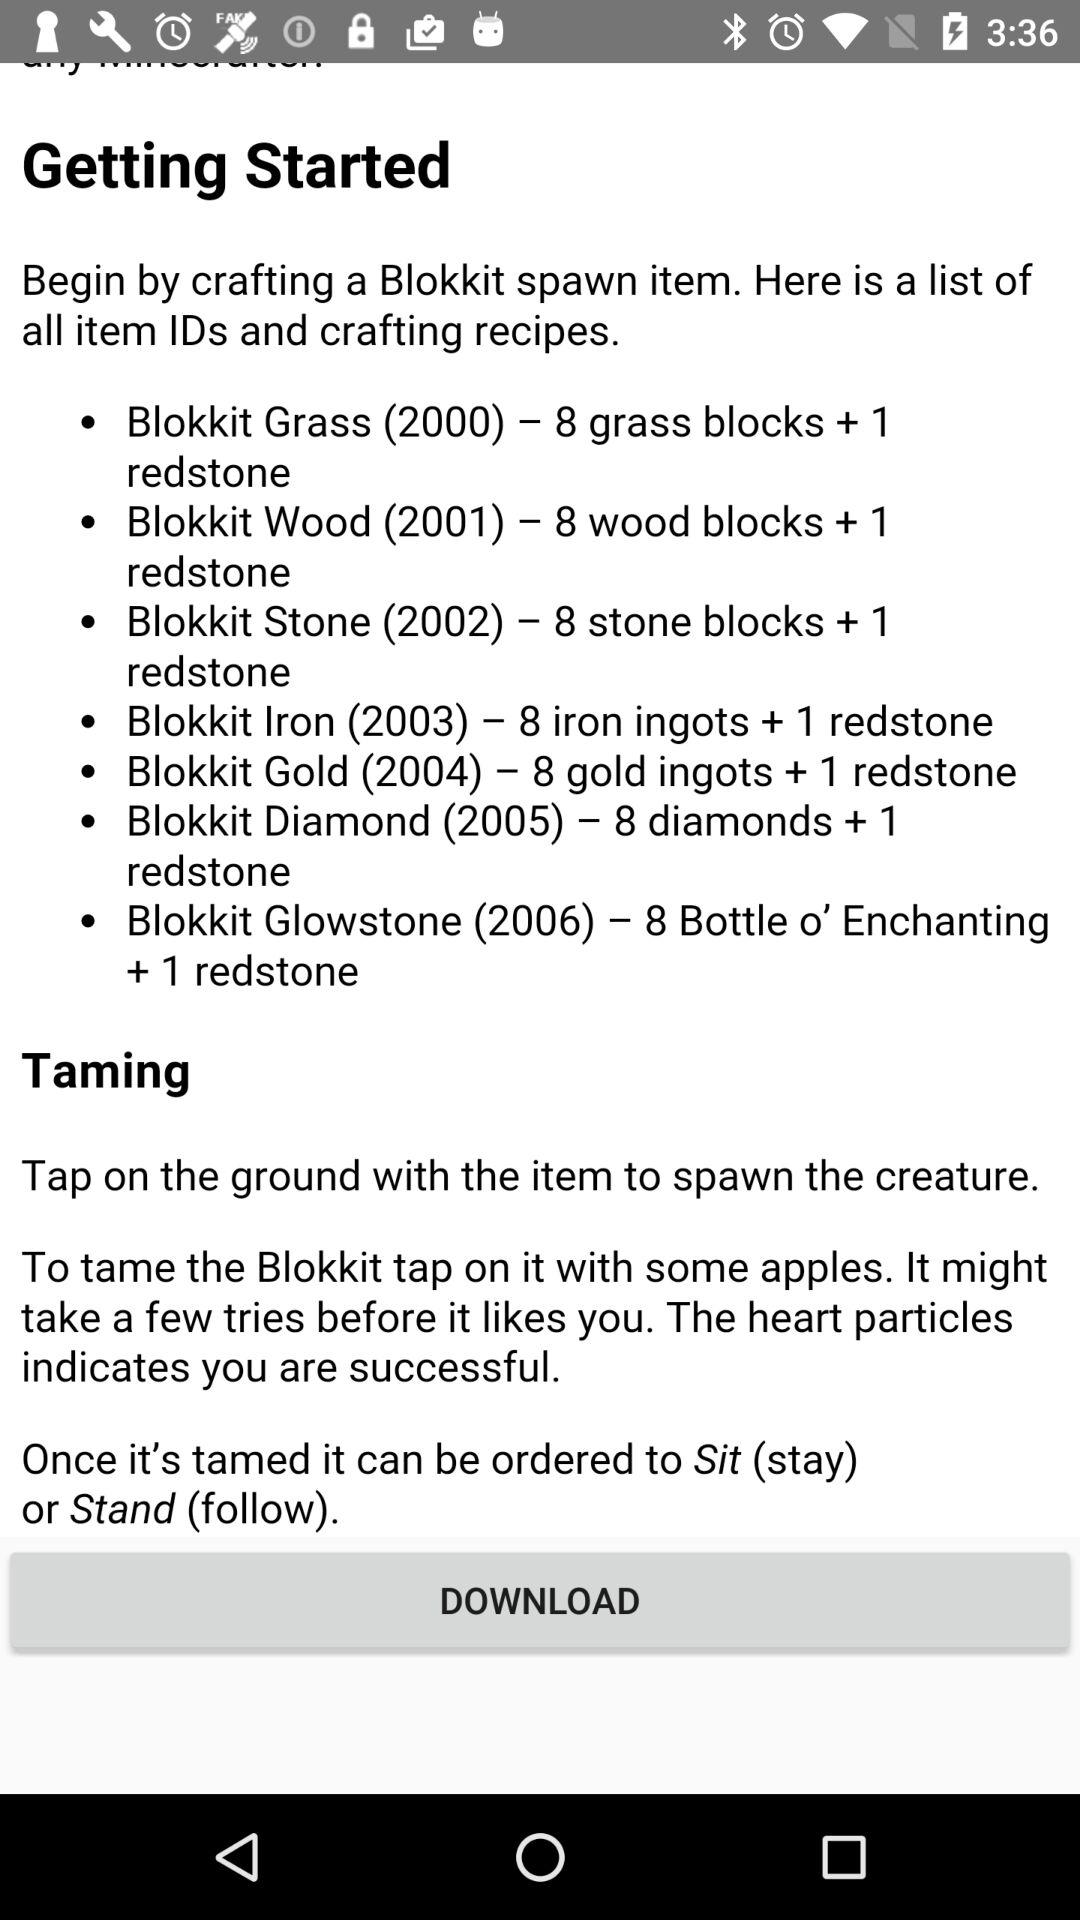What is taming? The taming is to "Tap on the ground with the item to spawn the creature". 